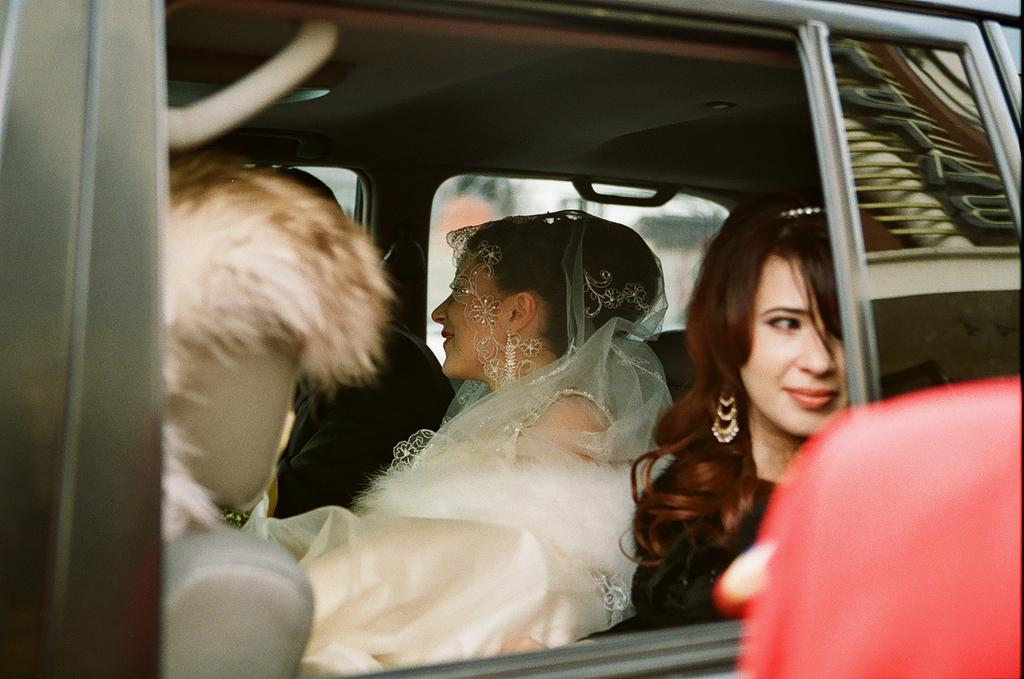What is the main subject of the image? The main subject of the image is a car. Who are the people inside the car? There is a bride, a bridegroom, and another lady sitting with them in the car. What is the effect of the sleet on the car in the image? There is no mention of sleet in the image, so it cannot be determined what effect it might have on the car. 